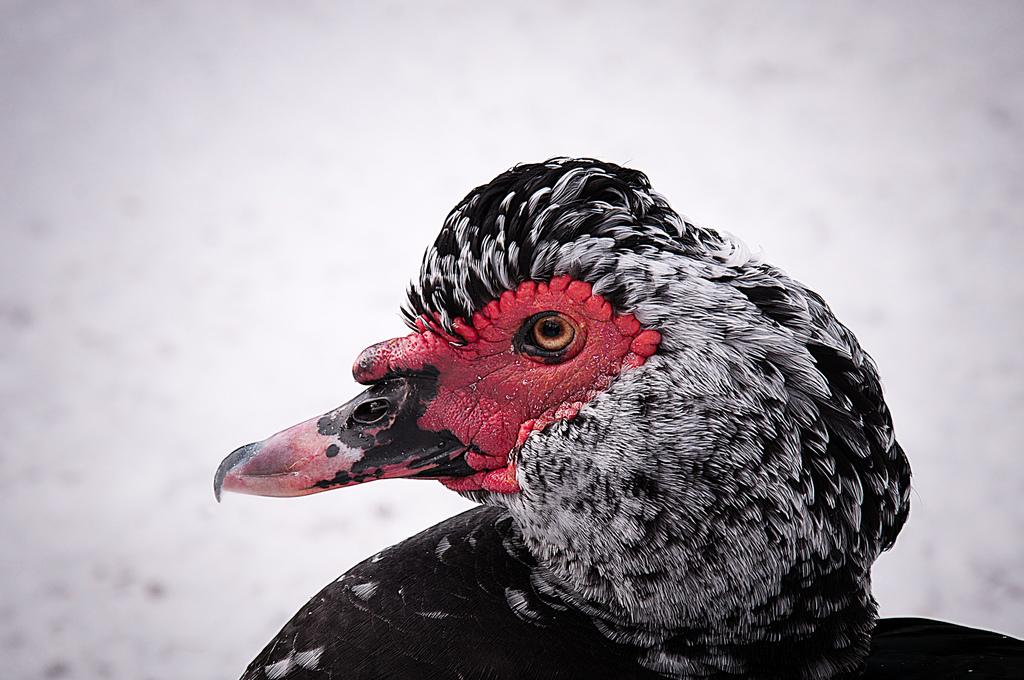What type of animal is in the image? There is a bird in the image. What colors can be seen on the bird? The bird has black and white coloring, and its face is red. What is the background color in the image? The background in the image is white. What type of nerve can be seen in the bird's wing in the image? There is no nerve visible in the image; it is a bird with black, white, and red coloring on a white background. 